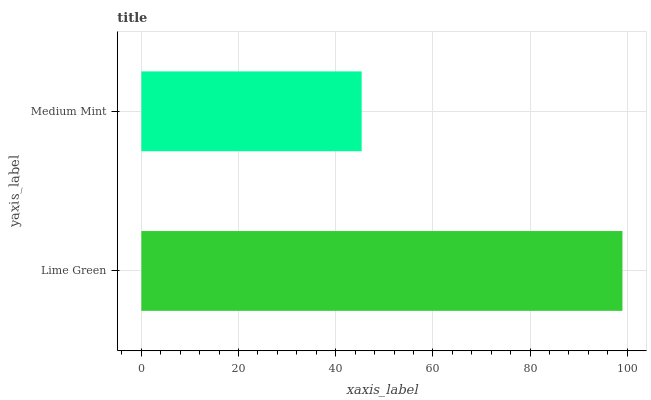Is Medium Mint the minimum?
Answer yes or no. Yes. Is Lime Green the maximum?
Answer yes or no. Yes. Is Medium Mint the maximum?
Answer yes or no. No. Is Lime Green greater than Medium Mint?
Answer yes or no. Yes. Is Medium Mint less than Lime Green?
Answer yes or no. Yes. Is Medium Mint greater than Lime Green?
Answer yes or no. No. Is Lime Green less than Medium Mint?
Answer yes or no. No. Is Lime Green the high median?
Answer yes or no. Yes. Is Medium Mint the low median?
Answer yes or no. Yes. Is Medium Mint the high median?
Answer yes or no. No. Is Lime Green the low median?
Answer yes or no. No. 